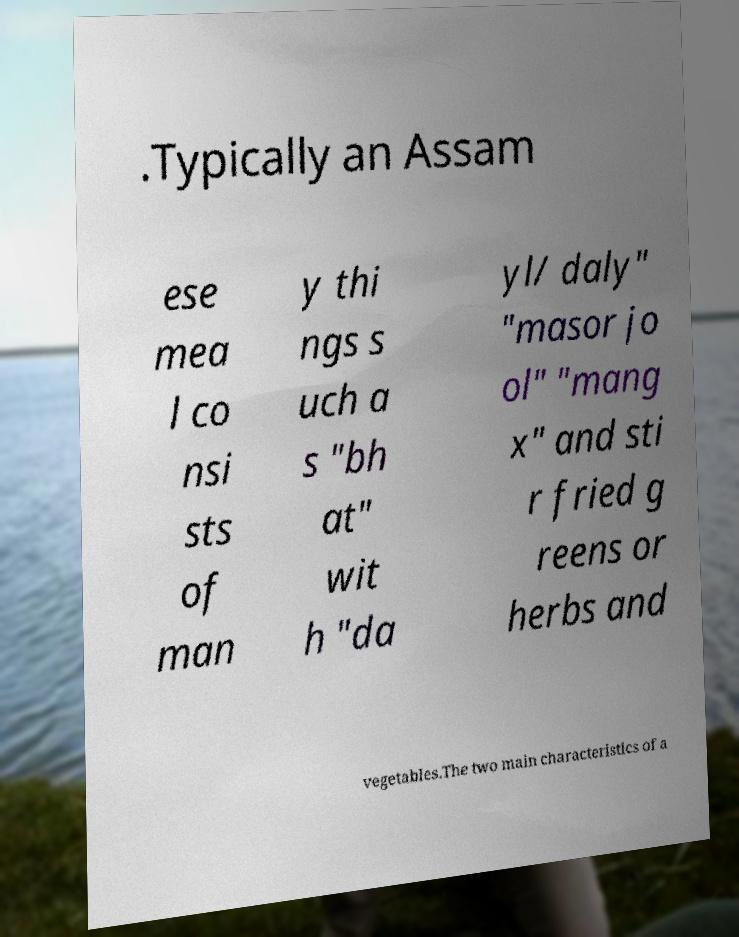Can you accurately transcribe the text from the provided image for me? .Typically an Assam ese mea l co nsi sts of man y thi ngs s uch a s "bh at" wit h "da yl/ daly" "masor jo ol" "mang x" and sti r fried g reens or herbs and vegetables.The two main characteristics of a 